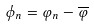<formula> <loc_0><loc_0><loc_500><loc_500>\phi _ { n } = \varphi _ { n } - \overline { \varphi }</formula> 